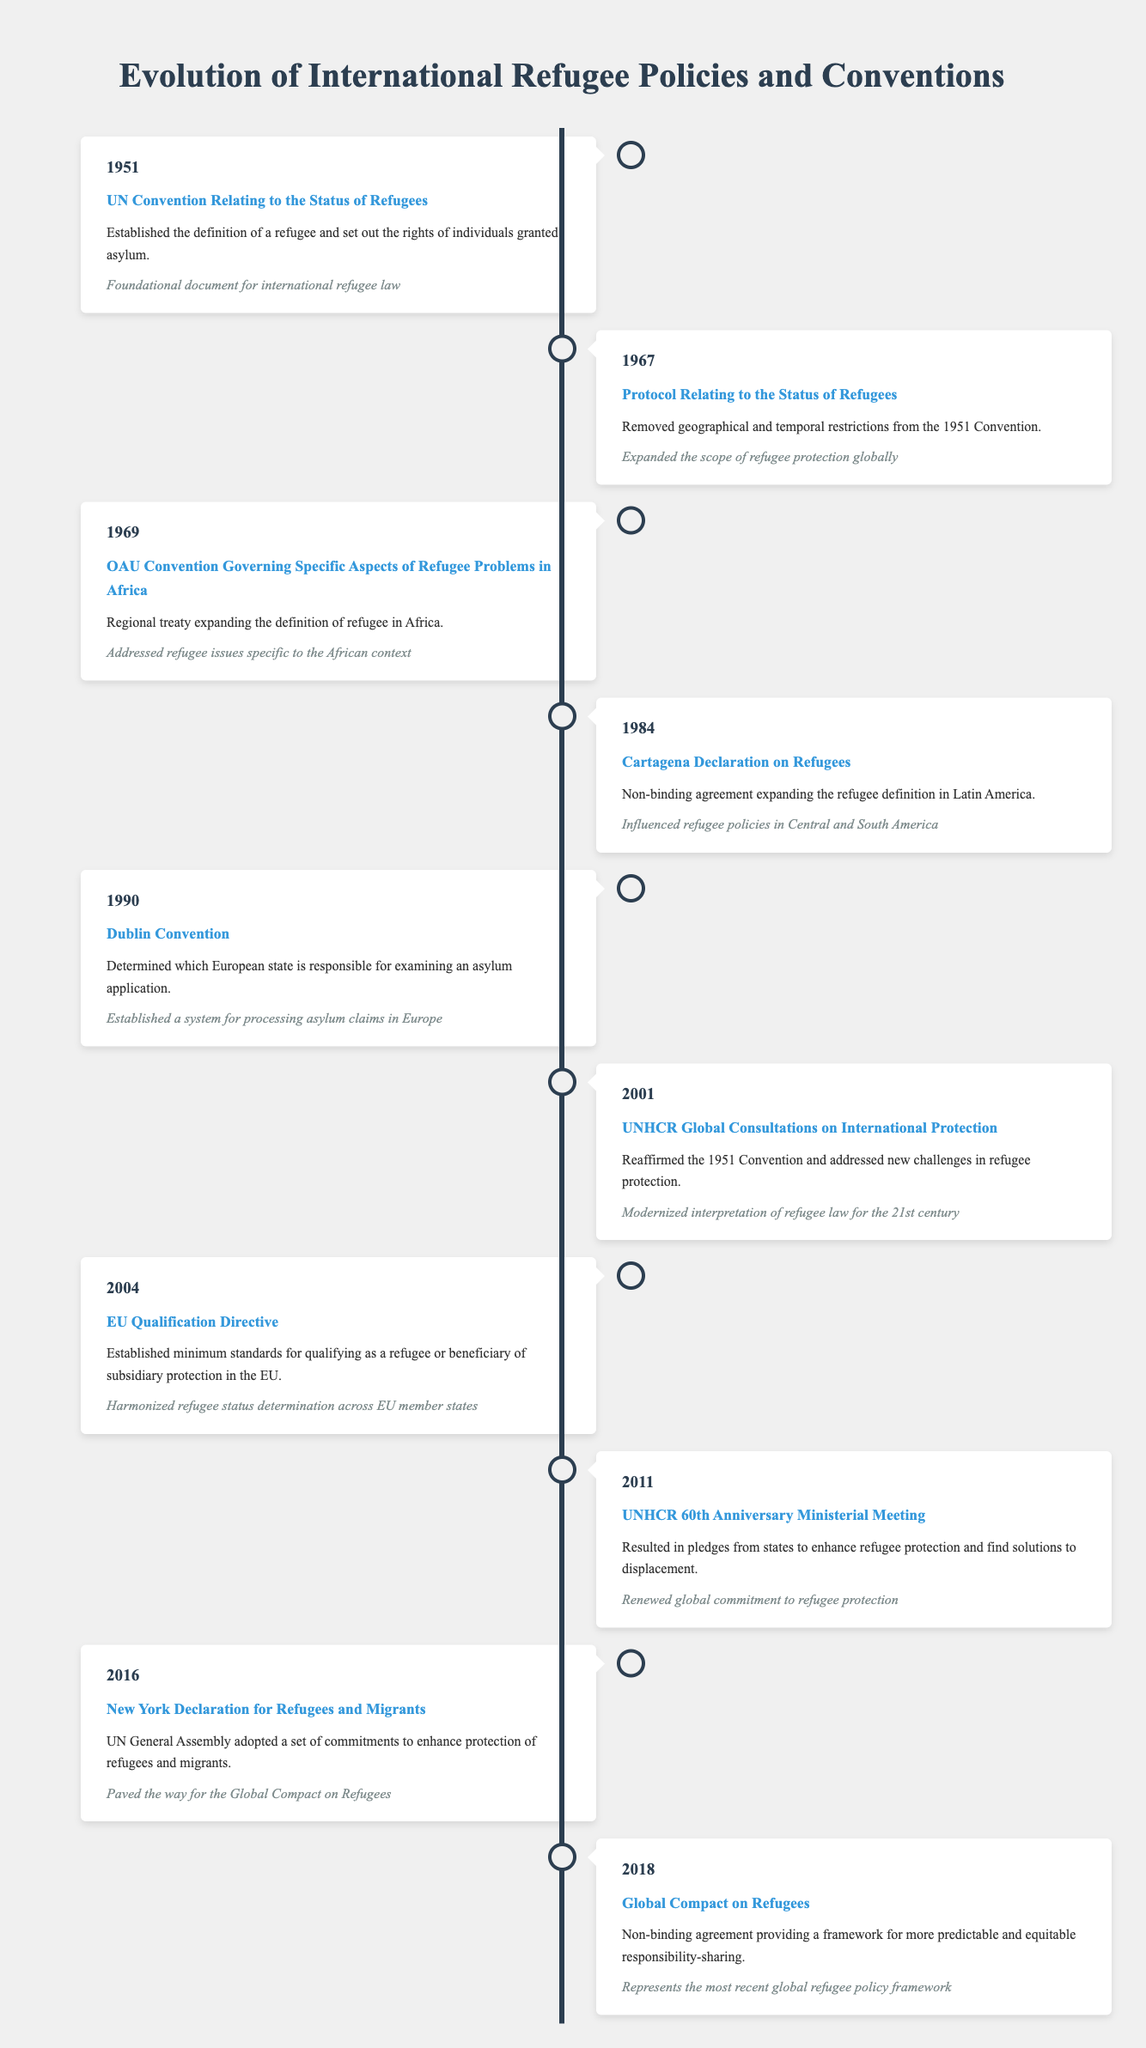What event took place in 1967? According to the table, the event listed for the year 1967 is the "Protocol Relating to the Status of Refugees."
Answer: Protocol Relating to the Status of Refugees How many total events are listed in the timeline? The timeline presents 10 distinct events from the years 1951 to 2018.
Answer: 10 Is the Dublin Convention a binding agreement? The Dublin Convention is classified as a binding treaty for processing asylum claims in Europe, making this statement true.
Answer: Yes What significant development occurred in 2011 regarding refugee protection? The table notes that in 2011, the UNHCR 60th Anniversary Ministerial Meeting resulted in pledges from states to enhance refugee protection, indicating a renewed commitment.
Answer: UNHCR 60th Anniversary Ministerial Meeting Which event signifies a departure from geographical limitations for refugee status, and in what year did it occur? The Protocol Relating to the Status of Refugees in 1967 is significant for removing geographical and temporal restrictions from the 1951 Convention.
Answer: Protocol Relating to the Status of Refugees, 1967 What is the significance of the Global Compact on Refugees established in 2018? The Global Compact on Refugees provides a framework for predictable and equitable responsibility-sharing, thus representing the most recent global refugee policy framework.
Answer: Framework for responsibility-sharing What year marked the adoption of the New York Declaration for Refugees and Migrants? The table shows that the New York Declaration for Refugees and Migrants was adopted in 2016.
Answer: 2016 Which two events involved a significant expansion of the refugee definition, and what regions did they pertain to? The OAU Convention in 1969 expanded the definition in Africa, and the Cartagena Declaration in 1984 expanded it in Latin America. Both events indicate regional efforts to redefine refugee parameters.
Answer: OAU Convention in Africa, Cartagena Declaration in Latin America What change in interpretation of refugee law was reaffirmed in 2001? The UNHCR Global Consultations on International Protection in 2001 reaffirmed the 1951 Convention and adapted it to new challenges in refugee protection for the 21st century, updating its interpretation.
Answer: Modernized interpretation of refugee law 